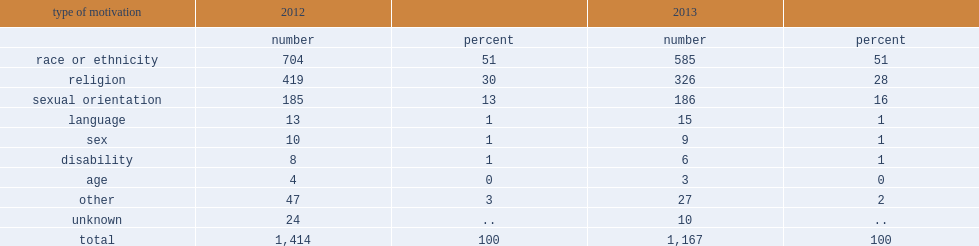How many incidents were motivated by hatred toward a race or ethnicity such as black, asian, arab or aboriginal populations in 2013? 585.0. What was the proportion of hate crimes were motivated by hatred toward a race or ethnicity such as black, asian, arab or aboriginal populations in 2013? 51.0. How many incidents were motivated by hatred towards a religious group, including hate crimes targeting jewish, muslim, catholic and other religious populations in 2013? 326.0. What was the proportion of incidents were motivated by hatred towards a religious group, including hate crimes targeting jewish, muslim, catholic and other religious populations in 2013? 28.0. How many incidents were motivated by hatred of a sexual orientation in 2013? 186.0. What was the proportion of incidents were motivated by hatred of a sexual orientation in 2013? 16.0. Parse the table in full. {'header': ['type of motivation', '2012', '', '2013', ''], 'rows': [['', 'number', 'percent', 'number', 'percent'], ['race or ethnicity', '704', '51', '585', '51'], ['religion', '419', '30', '326', '28'], ['sexual orientation', '185', '13', '186', '16'], ['language', '13', '1', '15', '1'], ['sex', '10', '1', '9', '1'], ['disability', '8', '1', '6', '1'], ['age', '4', '0', '3', '0'], ['other', '47', '3', '27', '2'], ['unknown', '24', '..', '10', '..'], ['total', '1,414', '100', '1,167', '100']]} 